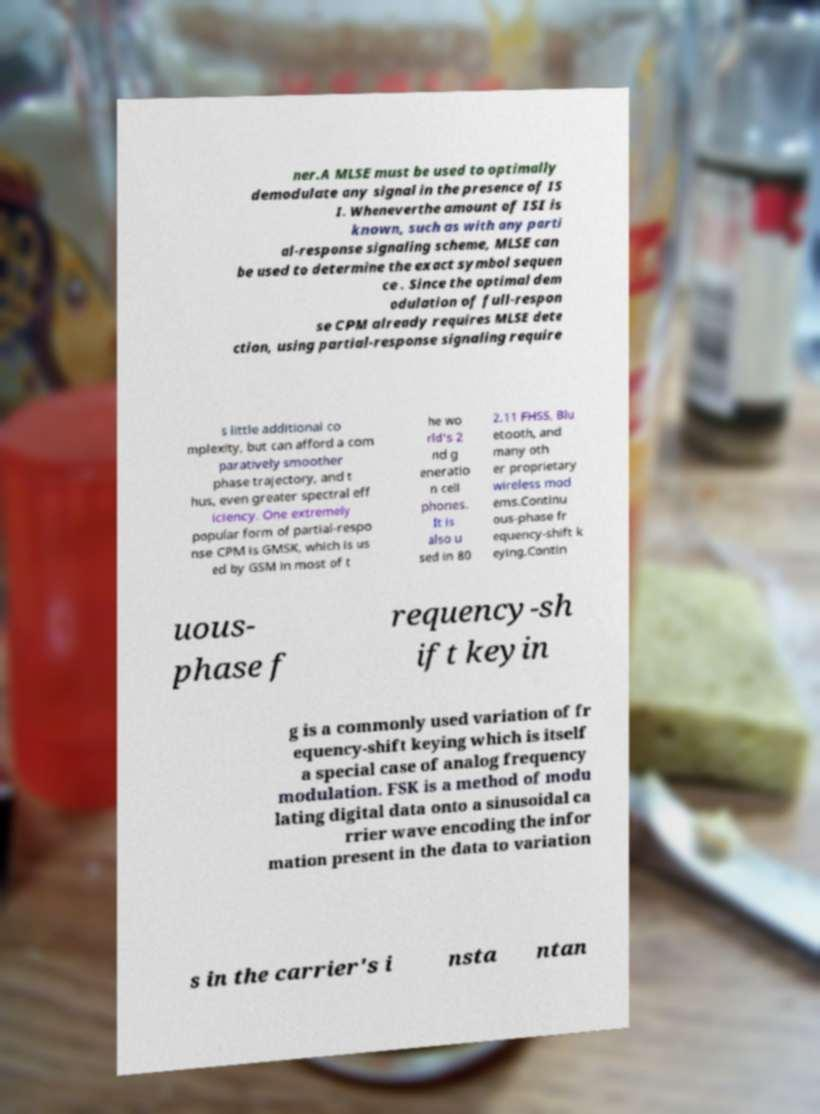Please read and relay the text visible in this image. What does it say? ner.A MLSE must be used to optimally demodulate any signal in the presence of IS I. Wheneverthe amount of ISI is known, such as with any parti al-response signaling scheme, MLSE can be used to determine the exact symbol sequen ce . Since the optimal dem odulation of full-respon se CPM already requires MLSE dete ction, using partial-response signaling require s little additional co mplexity, but can afford a com paratively smoother phase trajectory, and t hus, even greater spectral eff iciency. One extremely popular form of partial-respo nse CPM is GMSK, which is us ed by GSM in most of t he wo rld's 2 nd g eneratio n cell phones. It is also u sed in 80 2.11 FHSS, Blu etooth, and many oth er proprietary wireless mod ems.Continu ous-phase fr equency-shift k eying.Contin uous- phase f requency-sh ift keyin g is a commonly used variation of fr equency-shift keying which is itself a special case of analog frequency modulation. FSK is a method of modu lating digital data onto a sinusoidal ca rrier wave encoding the infor mation present in the data to variation s in the carrier's i nsta ntan 